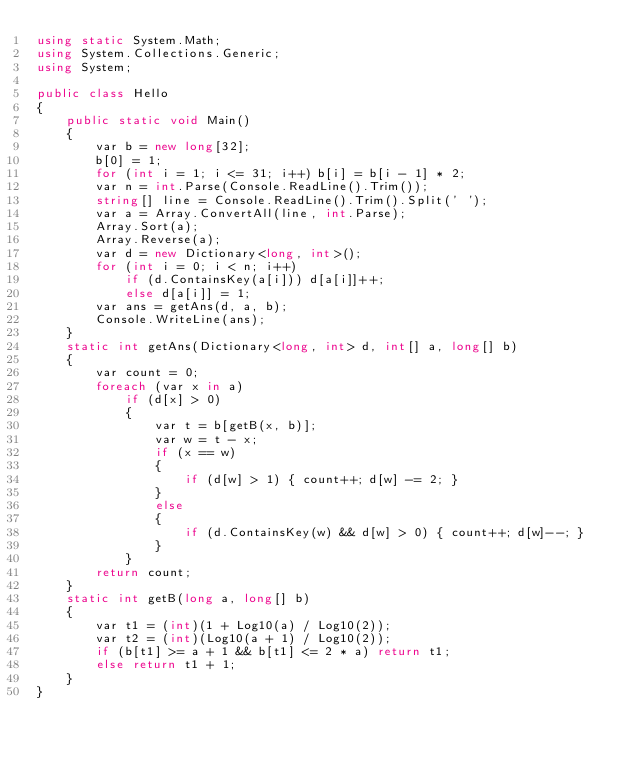Convert code to text. <code><loc_0><loc_0><loc_500><loc_500><_C#_>using static System.Math;
using System.Collections.Generic;
using System;

public class Hello
{
    public static void Main()
    {
        var b = new long[32];
        b[0] = 1;
        for (int i = 1; i <= 31; i++) b[i] = b[i - 1] * 2;
        var n = int.Parse(Console.ReadLine().Trim());
        string[] line = Console.ReadLine().Trim().Split(' ');
        var a = Array.ConvertAll(line, int.Parse);
        Array.Sort(a);
        Array.Reverse(a);
        var d = new Dictionary<long, int>();
        for (int i = 0; i < n; i++)
            if (d.ContainsKey(a[i])) d[a[i]]++;
            else d[a[i]] = 1;
        var ans = getAns(d, a, b);
        Console.WriteLine(ans);
    }
    static int getAns(Dictionary<long, int> d, int[] a, long[] b)
    {
        var count = 0;
        foreach (var x in a)
            if (d[x] > 0)
            {
                var t = b[getB(x, b)];
                var w = t - x;
                if (x == w)
                {
                    if (d[w] > 1) { count++; d[w] -= 2; }
                }
                else
                {
                    if (d.ContainsKey(w) && d[w] > 0) { count++; d[w]--; }
                }
            }
        return count;
    }
    static int getB(long a, long[] b)
    {
        var t1 = (int)(1 + Log10(a) / Log10(2));
        var t2 = (int)(Log10(a + 1) / Log10(2));
        if (b[t1] >= a + 1 && b[t1] <= 2 * a) return t1;
        else return t1 + 1;
    }
}</code> 